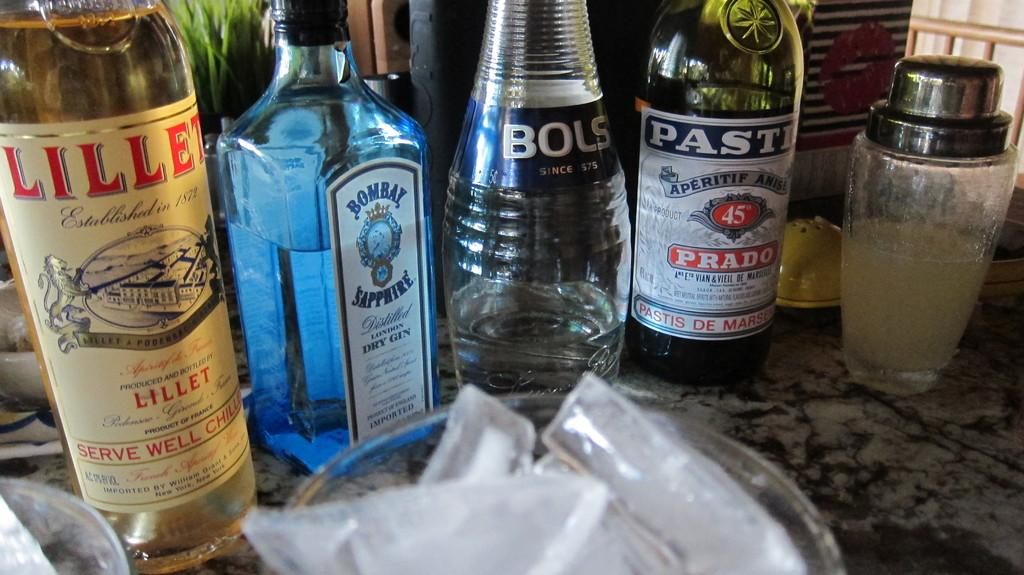<image>
Describe the image concisely. A bottle of Bombay Sapphire gin sits among three other bottles of alcohol. 